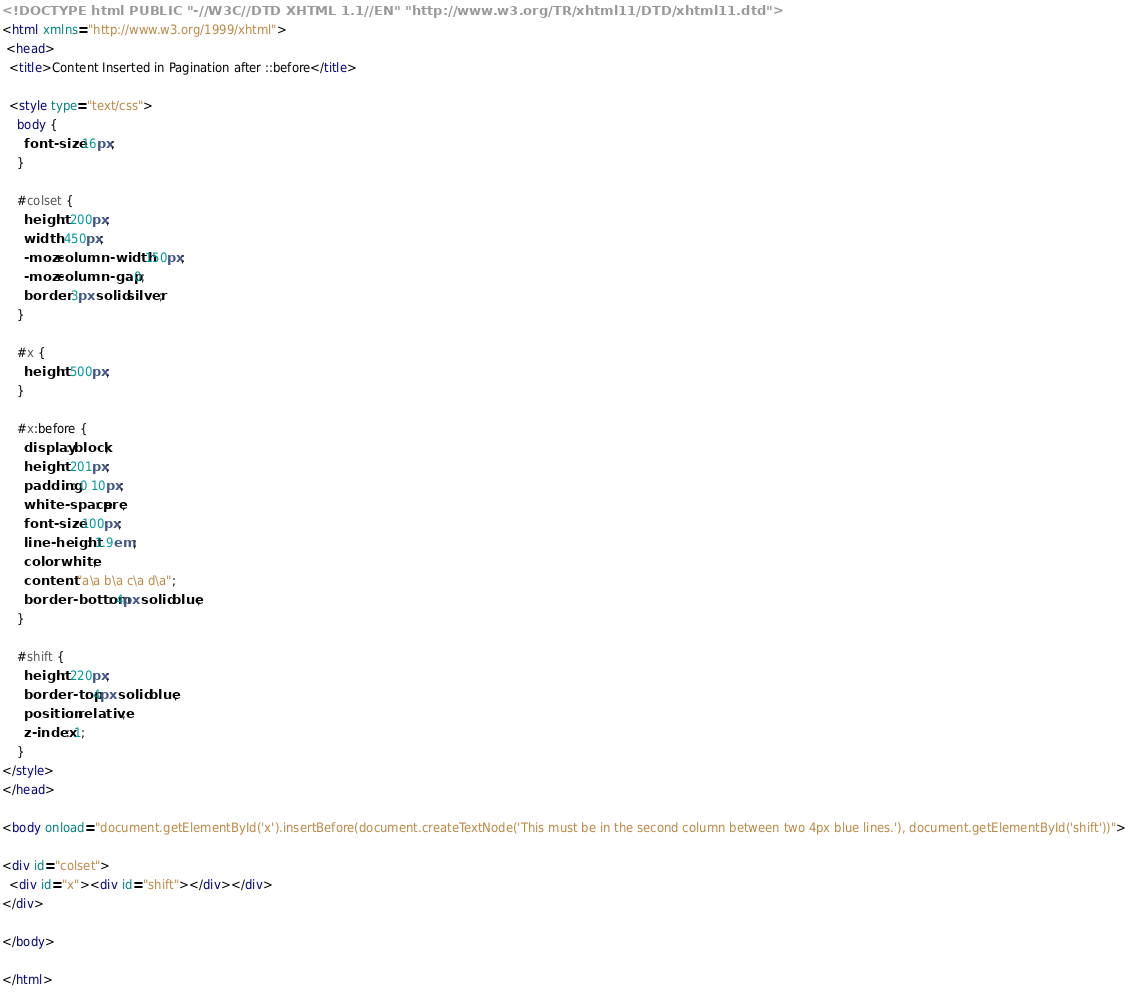Convert code to text. <code><loc_0><loc_0><loc_500><loc_500><_HTML_><!DOCTYPE html PUBLIC "-//W3C//DTD XHTML 1.1//EN" "http://www.w3.org/TR/xhtml11/DTD/xhtml11.dtd">
<html xmlns="http://www.w3.org/1999/xhtml">
 <head>
  <title>Content Inserted in Pagination after ::before</title>

  <style type="text/css">
    body {
      font-size: 16px;
    }

    #colset {
      height: 200px;
      width: 450px;
      -moz-column-width: 150px;
      -moz-column-gap: 0;
      border: 3px solid silver;
    }

    #x {
      height: 500px;
    }

    #x:before {
      display: block;
      height: 201px;
      padding: 0 10px;
      white-space: pre;
      font-size: 100px;
      line-height: 1.9em;
      color: white;
      content: "a\a b\a c\a d\a";
      border-bottom: 4px solid blue;
    }

    #shift {
      height: 220px;
      border-top: 4px solid blue;
      position: relative;
      z-index: 1;
    }
</style>
</head>

<body onload="document.getElementById('x').insertBefore(document.createTextNode('This must be in the second column between two 4px blue lines.'), document.getElementById('shift'))">

<div id="colset">
  <div id="x"><div id="shift"></div></div>
</div>

</body>

</html>
</code> 